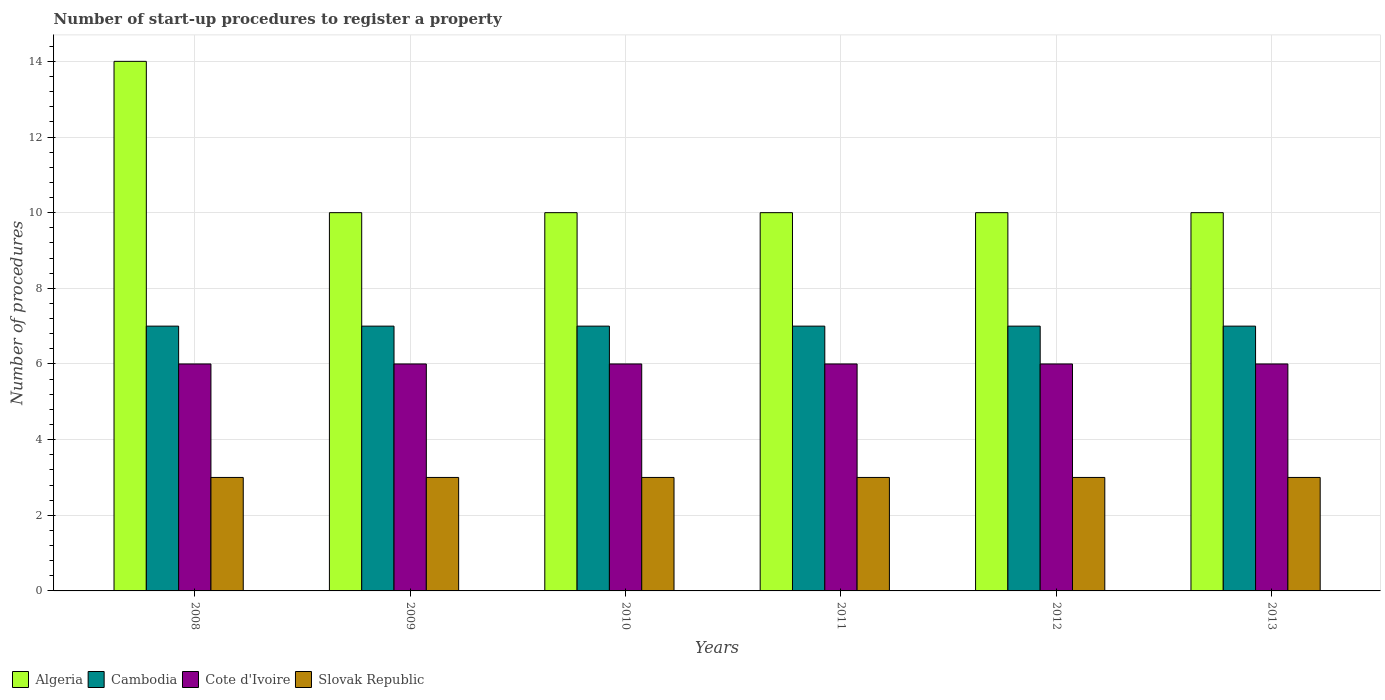How many different coloured bars are there?
Provide a succinct answer. 4. Are the number of bars per tick equal to the number of legend labels?
Provide a succinct answer. Yes. How many bars are there on the 2nd tick from the left?
Your answer should be compact. 4. How many bars are there on the 1st tick from the right?
Offer a very short reply. 4. What is the label of the 1st group of bars from the left?
Ensure brevity in your answer.  2008. What is the number of procedures required to register a property in Slovak Republic in 2008?
Your answer should be very brief. 3. Across all years, what is the maximum number of procedures required to register a property in Algeria?
Offer a very short reply. 14. Across all years, what is the minimum number of procedures required to register a property in Cambodia?
Your answer should be very brief. 7. In which year was the number of procedures required to register a property in Algeria maximum?
Offer a terse response. 2008. What is the total number of procedures required to register a property in Cote d'Ivoire in the graph?
Offer a very short reply. 36. What is the difference between the number of procedures required to register a property in Cambodia in 2010 and that in 2013?
Provide a short and direct response. 0. What is the difference between the number of procedures required to register a property in Cote d'Ivoire in 2008 and the number of procedures required to register a property in Slovak Republic in 2009?
Your answer should be very brief. 3. In the year 2008, what is the difference between the number of procedures required to register a property in Cote d'Ivoire and number of procedures required to register a property in Cambodia?
Provide a succinct answer. -1. What is the ratio of the number of procedures required to register a property in Slovak Republic in 2008 to that in 2010?
Give a very brief answer. 1. Is the number of procedures required to register a property in Algeria in 2008 less than that in 2012?
Provide a succinct answer. No. Is the difference between the number of procedures required to register a property in Cote d'Ivoire in 2009 and 2012 greater than the difference between the number of procedures required to register a property in Cambodia in 2009 and 2012?
Your answer should be very brief. No. What is the difference between the highest and the lowest number of procedures required to register a property in Cote d'Ivoire?
Your response must be concise. 0. Is the sum of the number of procedures required to register a property in Slovak Republic in 2008 and 2013 greater than the maximum number of procedures required to register a property in Cambodia across all years?
Give a very brief answer. No. What does the 1st bar from the left in 2008 represents?
Your answer should be very brief. Algeria. What does the 1st bar from the right in 2013 represents?
Ensure brevity in your answer.  Slovak Republic. Is it the case that in every year, the sum of the number of procedures required to register a property in Slovak Republic and number of procedures required to register a property in Algeria is greater than the number of procedures required to register a property in Cambodia?
Give a very brief answer. Yes. How many years are there in the graph?
Give a very brief answer. 6. What is the difference between two consecutive major ticks on the Y-axis?
Provide a succinct answer. 2. How many legend labels are there?
Provide a succinct answer. 4. How are the legend labels stacked?
Offer a very short reply. Horizontal. What is the title of the graph?
Ensure brevity in your answer.  Number of start-up procedures to register a property. What is the label or title of the X-axis?
Your answer should be compact. Years. What is the label or title of the Y-axis?
Offer a very short reply. Number of procedures. What is the Number of procedures in Algeria in 2008?
Give a very brief answer. 14. What is the Number of procedures in Cote d'Ivoire in 2009?
Provide a succinct answer. 6. What is the Number of procedures in Cambodia in 2010?
Keep it short and to the point. 7. What is the Number of procedures of Cote d'Ivoire in 2010?
Offer a very short reply. 6. What is the Number of procedures of Cambodia in 2011?
Your answer should be very brief. 7. What is the Number of procedures in Slovak Republic in 2011?
Provide a short and direct response. 3. What is the Number of procedures in Algeria in 2012?
Provide a short and direct response. 10. What is the Number of procedures in Cambodia in 2012?
Offer a terse response. 7. What is the Number of procedures in Cote d'Ivoire in 2012?
Offer a terse response. 6. What is the Number of procedures of Slovak Republic in 2012?
Ensure brevity in your answer.  3. What is the Number of procedures in Cambodia in 2013?
Your answer should be very brief. 7. Across all years, what is the maximum Number of procedures in Cambodia?
Your answer should be very brief. 7. Across all years, what is the maximum Number of procedures in Cote d'Ivoire?
Your response must be concise. 6. Across all years, what is the minimum Number of procedures in Algeria?
Give a very brief answer. 10. Across all years, what is the minimum Number of procedures of Cambodia?
Keep it short and to the point. 7. Across all years, what is the minimum Number of procedures in Cote d'Ivoire?
Your answer should be compact. 6. Across all years, what is the minimum Number of procedures of Slovak Republic?
Offer a very short reply. 3. What is the total Number of procedures of Algeria in the graph?
Make the answer very short. 64. What is the total Number of procedures in Slovak Republic in the graph?
Your answer should be compact. 18. What is the difference between the Number of procedures in Cambodia in 2008 and that in 2009?
Provide a short and direct response. 0. What is the difference between the Number of procedures of Cote d'Ivoire in 2008 and that in 2009?
Give a very brief answer. 0. What is the difference between the Number of procedures of Slovak Republic in 2008 and that in 2009?
Make the answer very short. 0. What is the difference between the Number of procedures in Algeria in 2008 and that in 2010?
Make the answer very short. 4. What is the difference between the Number of procedures in Cambodia in 2008 and that in 2010?
Offer a very short reply. 0. What is the difference between the Number of procedures in Cote d'Ivoire in 2008 and that in 2010?
Offer a terse response. 0. What is the difference between the Number of procedures of Slovak Republic in 2008 and that in 2010?
Offer a terse response. 0. What is the difference between the Number of procedures in Slovak Republic in 2008 and that in 2011?
Provide a short and direct response. 0. What is the difference between the Number of procedures of Algeria in 2008 and that in 2012?
Provide a succinct answer. 4. What is the difference between the Number of procedures in Algeria in 2008 and that in 2013?
Provide a short and direct response. 4. What is the difference between the Number of procedures in Cambodia in 2008 and that in 2013?
Your answer should be very brief. 0. What is the difference between the Number of procedures of Slovak Republic in 2008 and that in 2013?
Provide a succinct answer. 0. What is the difference between the Number of procedures in Cote d'Ivoire in 2009 and that in 2010?
Provide a short and direct response. 0. What is the difference between the Number of procedures of Algeria in 2009 and that in 2012?
Offer a terse response. 0. What is the difference between the Number of procedures of Cambodia in 2009 and that in 2012?
Ensure brevity in your answer.  0. What is the difference between the Number of procedures in Cambodia in 2009 and that in 2013?
Provide a short and direct response. 0. What is the difference between the Number of procedures of Slovak Republic in 2009 and that in 2013?
Your response must be concise. 0. What is the difference between the Number of procedures of Algeria in 2010 and that in 2011?
Offer a very short reply. 0. What is the difference between the Number of procedures of Slovak Republic in 2010 and that in 2011?
Your answer should be very brief. 0. What is the difference between the Number of procedures in Algeria in 2010 and that in 2012?
Keep it short and to the point. 0. What is the difference between the Number of procedures of Slovak Republic in 2010 and that in 2012?
Ensure brevity in your answer.  0. What is the difference between the Number of procedures in Cote d'Ivoire in 2010 and that in 2013?
Keep it short and to the point. 0. What is the difference between the Number of procedures in Cote d'Ivoire in 2011 and that in 2012?
Ensure brevity in your answer.  0. What is the difference between the Number of procedures of Slovak Republic in 2011 and that in 2012?
Make the answer very short. 0. What is the difference between the Number of procedures of Algeria in 2011 and that in 2013?
Your response must be concise. 0. What is the difference between the Number of procedures in Slovak Republic in 2011 and that in 2013?
Your answer should be compact. 0. What is the difference between the Number of procedures in Algeria in 2008 and the Number of procedures in Slovak Republic in 2009?
Keep it short and to the point. 11. What is the difference between the Number of procedures in Cambodia in 2008 and the Number of procedures in Cote d'Ivoire in 2009?
Ensure brevity in your answer.  1. What is the difference between the Number of procedures of Cote d'Ivoire in 2008 and the Number of procedures of Slovak Republic in 2009?
Keep it short and to the point. 3. What is the difference between the Number of procedures in Algeria in 2008 and the Number of procedures in Slovak Republic in 2010?
Provide a short and direct response. 11. What is the difference between the Number of procedures in Cambodia in 2008 and the Number of procedures in Cote d'Ivoire in 2010?
Keep it short and to the point. 1. What is the difference between the Number of procedures in Cambodia in 2008 and the Number of procedures in Slovak Republic in 2010?
Make the answer very short. 4. What is the difference between the Number of procedures of Algeria in 2008 and the Number of procedures of Cambodia in 2011?
Your answer should be very brief. 7. What is the difference between the Number of procedures of Algeria in 2008 and the Number of procedures of Slovak Republic in 2011?
Provide a short and direct response. 11. What is the difference between the Number of procedures of Cambodia in 2008 and the Number of procedures of Slovak Republic in 2011?
Ensure brevity in your answer.  4. What is the difference between the Number of procedures in Cote d'Ivoire in 2008 and the Number of procedures in Slovak Republic in 2011?
Offer a terse response. 3. What is the difference between the Number of procedures of Algeria in 2008 and the Number of procedures of Slovak Republic in 2012?
Ensure brevity in your answer.  11. What is the difference between the Number of procedures in Cambodia in 2008 and the Number of procedures in Slovak Republic in 2012?
Your answer should be compact. 4. What is the difference between the Number of procedures in Algeria in 2008 and the Number of procedures in Cote d'Ivoire in 2013?
Provide a succinct answer. 8. What is the difference between the Number of procedures in Algeria in 2008 and the Number of procedures in Slovak Republic in 2013?
Offer a very short reply. 11. What is the difference between the Number of procedures of Cambodia in 2008 and the Number of procedures of Cote d'Ivoire in 2013?
Provide a succinct answer. 1. What is the difference between the Number of procedures in Cambodia in 2008 and the Number of procedures in Slovak Republic in 2013?
Your response must be concise. 4. What is the difference between the Number of procedures of Cote d'Ivoire in 2008 and the Number of procedures of Slovak Republic in 2013?
Make the answer very short. 3. What is the difference between the Number of procedures in Algeria in 2009 and the Number of procedures in Cambodia in 2010?
Provide a succinct answer. 3. What is the difference between the Number of procedures in Algeria in 2009 and the Number of procedures in Slovak Republic in 2010?
Your answer should be compact. 7. What is the difference between the Number of procedures in Cambodia in 2009 and the Number of procedures in Slovak Republic in 2010?
Offer a very short reply. 4. What is the difference between the Number of procedures of Algeria in 2009 and the Number of procedures of Cote d'Ivoire in 2011?
Give a very brief answer. 4. What is the difference between the Number of procedures in Algeria in 2009 and the Number of procedures in Slovak Republic in 2011?
Offer a very short reply. 7. What is the difference between the Number of procedures in Cambodia in 2009 and the Number of procedures in Cote d'Ivoire in 2011?
Ensure brevity in your answer.  1. What is the difference between the Number of procedures of Algeria in 2009 and the Number of procedures of Slovak Republic in 2012?
Keep it short and to the point. 7. What is the difference between the Number of procedures of Cambodia in 2009 and the Number of procedures of Slovak Republic in 2012?
Offer a very short reply. 4. What is the difference between the Number of procedures in Algeria in 2009 and the Number of procedures in Cambodia in 2013?
Your answer should be compact. 3. What is the difference between the Number of procedures in Cambodia in 2009 and the Number of procedures in Cote d'Ivoire in 2013?
Keep it short and to the point. 1. What is the difference between the Number of procedures of Cambodia in 2009 and the Number of procedures of Slovak Republic in 2013?
Give a very brief answer. 4. What is the difference between the Number of procedures in Algeria in 2010 and the Number of procedures in Slovak Republic in 2011?
Provide a short and direct response. 7. What is the difference between the Number of procedures of Cambodia in 2010 and the Number of procedures of Cote d'Ivoire in 2011?
Your answer should be very brief. 1. What is the difference between the Number of procedures of Algeria in 2010 and the Number of procedures of Cambodia in 2012?
Your response must be concise. 3. What is the difference between the Number of procedures in Algeria in 2010 and the Number of procedures in Cote d'Ivoire in 2012?
Your answer should be compact. 4. What is the difference between the Number of procedures of Algeria in 2010 and the Number of procedures of Slovak Republic in 2012?
Make the answer very short. 7. What is the difference between the Number of procedures of Cote d'Ivoire in 2010 and the Number of procedures of Slovak Republic in 2012?
Make the answer very short. 3. What is the difference between the Number of procedures in Algeria in 2010 and the Number of procedures in Cote d'Ivoire in 2013?
Your response must be concise. 4. What is the difference between the Number of procedures of Algeria in 2010 and the Number of procedures of Slovak Republic in 2013?
Provide a short and direct response. 7. What is the difference between the Number of procedures of Cambodia in 2010 and the Number of procedures of Cote d'Ivoire in 2013?
Keep it short and to the point. 1. What is the difference between the Number of procedures of Cote d'Ivoire in 2010 and the Number of procedures of Slovak Republic in 2013?
Ensure brevity in your answer.  3. What is the difference between the Number of procedures in Algeria in 2011 and the Number of procedures in Cote d'Ivoire in 2012?
Keep it short and to the point. 4. What is the difference between the Number of procedures of Cambodia in 2011 and the Number of procedures of Slovak Republic in 2012?
Make the answer very short. 4. What is the difference between the Number of procedures in Algeria in 2011 and the Number of procedures in Cote d'Ivoire in 2013?
Provide a succinct answer. 4. What is the difference between the Number of procedures in Algeria in 2011 and the Number of procedures in Slovak Republic in 2013?
Ensure brevity in your answer.  7. What is the difference between the Number of procedures in Cambodia in 2011 and the Number of procedures in Cote d'Ivoire in 2013?
Provide a succinct answer. 1. What is the difference between the Number of procedures in Cambodia in 2011 and the Number of procedures in Slovak Republic in 2013?
Provide a succinct answer. 4. What is the difference between the Number of procedures of Algeria in 2012 and the Number of procedures of Slovak Republic in 2013?
Your response must be concise. 7. What is the difference between the Number of procedures of Cambodia in 2012 and the Number of procedures of Cote d'Ivoire in 2013?
Your answer should be very brief. 1. What is the difference between the Number of procedures of Cambodia in 2012 and the Number of procedures of Slovak Republic in 2013?
Your answer should be very brief. 4. What is the average Number of procedures of Algeria per year?
Make the answer very short. 10.67. What is the average Number of procedures of Slovak Republic per year?
Provide a short and direct response. 3. In the year 2008, what is the difference between the Number of procedures in Algeria and Number of procedures in Cambodia?
Your answer should be very brief. 7. In the year 2008, what is the difference between the Number of procedures in Cambodia and Number of procedures in Cote d'Ivoire?
Give a very brief answer. 1. In the year 2008, what is the difference between the Number of procedures of Cambodia and Number of procedures of Slovak Republic?
Provide a succinct answer. 4. In the year 2009, what is the difference between the Number of procedures in Algeria and Number of procedures in Cambodia?
Provide a succinct answer. 3. In the year 2009, what is the difference between the Number of procedures in Cambodia and Number of procedures in Cote d'Ivoire?
Ensure brevity in your answer.  1. In the year 2009, what is the difference between the Number of procedures in Cote d'Ivoire and Number of procedures in Slovak Republic?
Your answer should be compact. 3. In the year 2010, what is the difference between the Number of procedures of Algeria and Number of procedures of Cote d'Ivoire?
Provide a short and direct response. 4. In the year 2010, what is the difference between the Number of procedures in Algeria and Number of procedures in Slovak Republic?
Your response must be concise. 7. In the year 2011, what is the difference between the Number of procedures of Algeria and Number of procedures of Cambodia?
Ensure brevity in your answer.  3. In the year 2011, what is the difference between the Number of procedures in Algeria and Number of procedures in Cote d'Ivoire?
Provide a short and direct response. 4. In the year 2011, what is the difference between the Number of procedures in Cambodia and Number of procedures in Cote d'Ivoire?
Your answer should be compact. 1. In the year 2011, what is the difference between the Number of procedures in Cambodia and Number of procedures in Slovak Republic?
Make the answer very short. 4. In the year 2011, what is the difference between the Number of procedures of Cote d'Ivoire and Number of procedures of Slovak Republic?
Ensure brevity in your answer.  3. In the year 2012, what is the difference between the Number of procedures in Algeria and Number of procedures in Cote d'Ivoire?
Your answer should be compact. 4. In the year 2012, what is the difference between the Number of procedures of Algeria and Number of procedures of Slovak Republic?
Provide a short and direct response. 7. In the year 2012, what is the difference between the Number of procedures in Cambodia and Number of procedures in Cote d'Ivoire?
Offer a terse response. 1. In the year 2013, what is the difference between the Number of procedures of Algeria and Number of procedures of Cote d'Ivoire?
Give a very brief answer. 4. In the year 2013, what is the difference between the Number of procedures in Cambodia and Number of procedures in Cote d'Ivoire?
Your answer should be compact. 1. In the year 2013, what is the difference between the Number of procedures in Cambodia and Number of procedures in Slovak Republic?
Keep it short and to the point. 4. What is the ratio of the Number of procedures of Algeria in 2008 to that in 2009?
Provide a succinct answer. 1.4. What is the ratio of the Number of procedures in Algeria in 2008 to that in 2010?
Ensure brevity in your answer.  1.4. What is the ratio of the Number of procedures in Slovak Republic in 2008 to that in 2010?
Keep it short and to the point. 1. What is the ratio of the Number of procedures in Cambodia in 2008 to that in 2011?
Offer a very short reply. 1. What is the ratio of the Number of procedures in Cote d'Ivoire in 2008 to that in 2012?
Your answer should be compact. 1. What is the ratio of the Number of procedures in Slovak Republic in 2008 to that in 2012?
Your answer should be very brief. 1. What is the ratio of the Number of procedures of Cambodia in 2008 to that in 2013?
Provide a succinct answer. 1. What is the ratio of the Number of procedures in Cote d'Ivoire in 2008 to that in 2013?
Your response must be concise. 1. What is the ratio of the Number of procedures of Slovak Republic in 2008 to that in 2013?
Ensure brevity in your answer.  1. What is the ratio of the Number of procedures of Cambodia in 2009 to that in 2010?
Your response must be concise. 1. What is the ratio of the Number of procedures in Cote d'Ivoire in 2009 to that in 2010?
Give a very brief answer. 1. What is the ratio of the Number of procedures of Slovak Republic in 2009 to that in 2010?
Your answer should be compact. 1. What is the ratio of the Number of procedures of Algeria in 2009 to that in 2011?
Your response must be concise. 1. What is the ratio of the Number of procedures of Cambodia in 2009 to that in 2011?
Keep it short and to the point. 1. What is the ratio of the Number of procedures in Cote d'Ivoire in 2009 to that in 2012?
Provide a succinct answer. 1. What is the ratio of the Number of procedures of Cambodia in 2009 to that in 2013?
Keep it short and to the point. 1. What is the ratio of the Number of procedures in Cote d'Ivoire in 2009 to that in 2013?
Make the answer very short. 1. What is the ratio of the Number of procedures of Algeria in 2010 to that in 2011?
Provide a succinct answer. 1. What is the ratio of the Number of procedures in Cambodia in 2010 to that in 2011?
Ensure brevity in your answer.  1. What is the ratio of the Number of procedures in Cote d'Ivoire in 2010 to that in 2011?
Your answer should be very brief. 1. What is the ratio of the Number of procedures of Cambodia in 2010 to that in 2012?
Make the answer very short. 1. What is the ratio of the Number of procedures of Cote d'Ivoire in 2010 to that in 2012?
Make the answer very short. 1. What is the ratio of the Number of procedures in Algeria in 2010 to that in 2013?
Give a very brief answer. 1. What is the ratio of the Number of procedures of Cambodia in 2010 to that in 2013?
Your answer should be compact. 1. What is the ratio of the Number of procedures of Cote d'Ivoire in 2010 to that in 2013?
Your response must be concise. 1. What is the ratio of the Number of procedures in Slovak Republic in 2010 to that in 2013?
Offer a very short reply. 1. What is the ratio of the Number of procedures in Algeria in 2011 to that in 2012?
Offer a terse response. 1. What is the ratio of the Number of procedures of Slovak Republic in 2011 to that in 2012?
Your answer should be compact. 1. What is the ratio of the Number of procedures of Algeria in 2011 to that in 2013?
Keep it short and to the point. 1. What is the ratio of the Number of procedures in Cambodia in 2011 to that in 2013?
Make the answer very short. 1. What is the ratio of the Number of procedures in Cote d'Ivoire in 2011 to that in 2013?
Ensure brevity in your answer.  1. What is the ratio of the Number of procedures of Algeria in 2012 to that in 2013?
Your answer should be very brief. 1. What is the ratio of the Number of procedures of Cambodia in 2012 to that in 2013?
Your answer should be very brief. 1. What is the ratio of the Number of procedures in Cote d'Ivoire in 2012 to that in 2013?
Ensure brevity in your answer.  1. What is the difference between the highest and the second highest Number of procedures of Slovak Republic?
Ensure brevity in your answer.  0. What is the difference between the highest and the lowest Number of procedures of Algeria?
Make the answer very short. 4. 